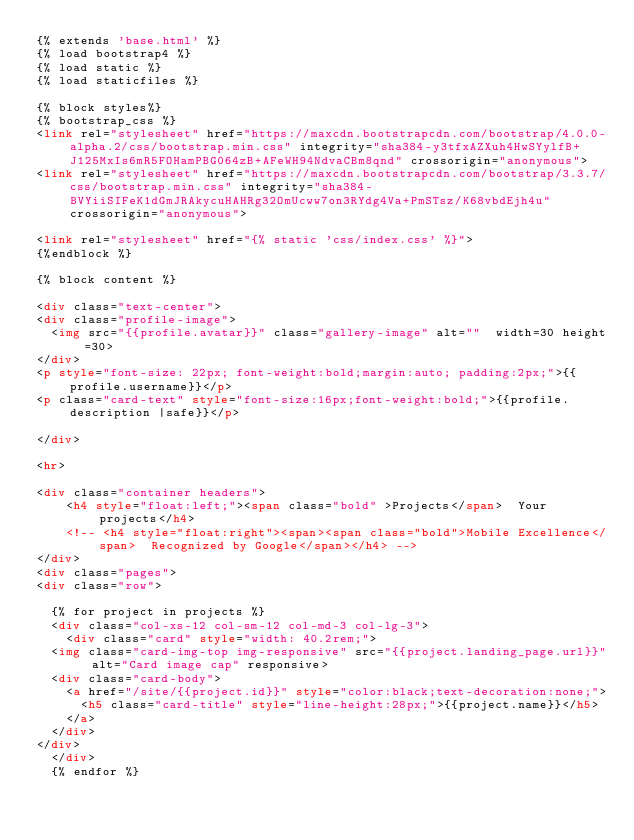Convert code to text. <code><loc_0><loc_0><loc_500><loc_500><_HTML_>{% extends 'base.html' %}
{% load bootstrap4 %}
{% load static %}
{% load staticfiles %}

{% block styles%}
{% bootstrap_css %}
<link rel="stylesheet" href="https://maxcdn.bootstrapcdn.com/bootstrap/4.0.0-alpha.2/css/bootstrap.min.css" integrity="sha384-y3tfxAZXuh4HwSYylfB+J125MxIs6mR5FOHamPBG064zB+AFeWH94NdvaCBm8qnd" crossorigin="anonymous">
<link rel="stylesheet" href="https://maxcdn.bootstrapcdn.com/bootstrap/3.3.7/css/bootstrap.min.css" integrity="sha384-BVYiiSIFeK1dGmJRAkycuHAHRg32OmUcww7on3RYdg4Va+PmSTsz/K68vbdEjh4u" crossorigin="anonymous">

<link rel="stylesheet" href="{% static 'css/index.css' %}">
{%endblock %}

{% block content %}

<div class="text-center">
<div class="profile-image">
  <img src="{{profile.avatar}}" class="gallery-image" alt=""  width=30 height=30>
</div>
<p style="font-size: 22px; font-weight:bold;margin:auto; padding:2px;">{{profile.username}}</p>
<p class="card-text" style="font-size:16px;font-weight:bold;">{{profile.description |safe}}</p>

</div>

<hr>

<div class="container headers">
    <h4 style="float:left;"><span class="bold" >Projects</span>  Your projects</h4>
    <!-- <h4 style="float:right"><span><span class="bold">Mobile Excellence</span>  Recognized by Google</span></h4> -->
</div>
<div class="pages">
<div class="row">

  {% for project in projects %}
  <div class="col-xs-12 col-sm-12 col-md-3 col-lg-3">
    <div class="card" style="width: 40.2rem;">
  <img class="card-img-top img-responsive" src="{{project.landing_page.url}}" alt="Card image cap" responsive>
  <div class="card-body">
    <a href="/site/{{project.id}}" style="color:black;text-decoration:none;">
      <h5 class="card-title" style="line-height:28px;">{{project.name}}</h5>
    </a>
  </div>
</div>
  </div>
  {% endfor %}
</code> 